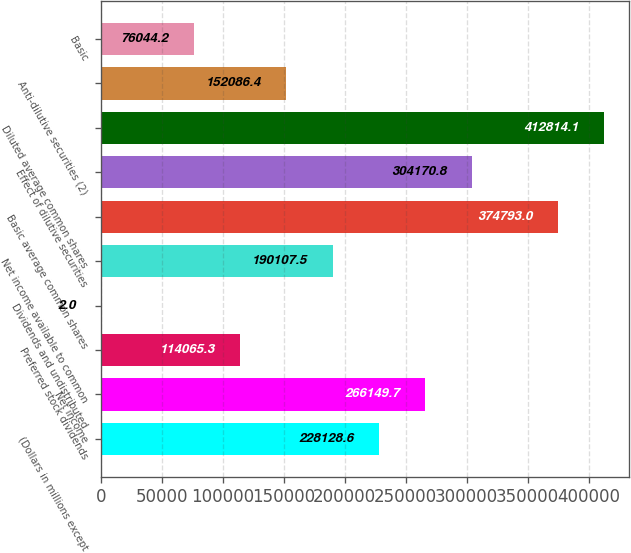Convert chart to OTSL. <chart><loc_0><loc_0><loc_500><loc_500><bar_chart><fcel>(Dollars in millions except<fcel>Net income<fcel>Preferred stock dividends<fcel>Dividends and undistributed<fcel>Net income available to common<fcel>Basic average common shares<fcel>Effect of dilutive securities<fcel>Diluted average common shares<fcel>Anti-dilutive securities (2)<fcel>Basic<nl><fcel>228129<fcel>266150<fcel>114065<fcel>2<fcel>190108<fcel>374793<fcel>304171<fcel>412814<fcel>152086<fcel>76044.2<nl></chart> 